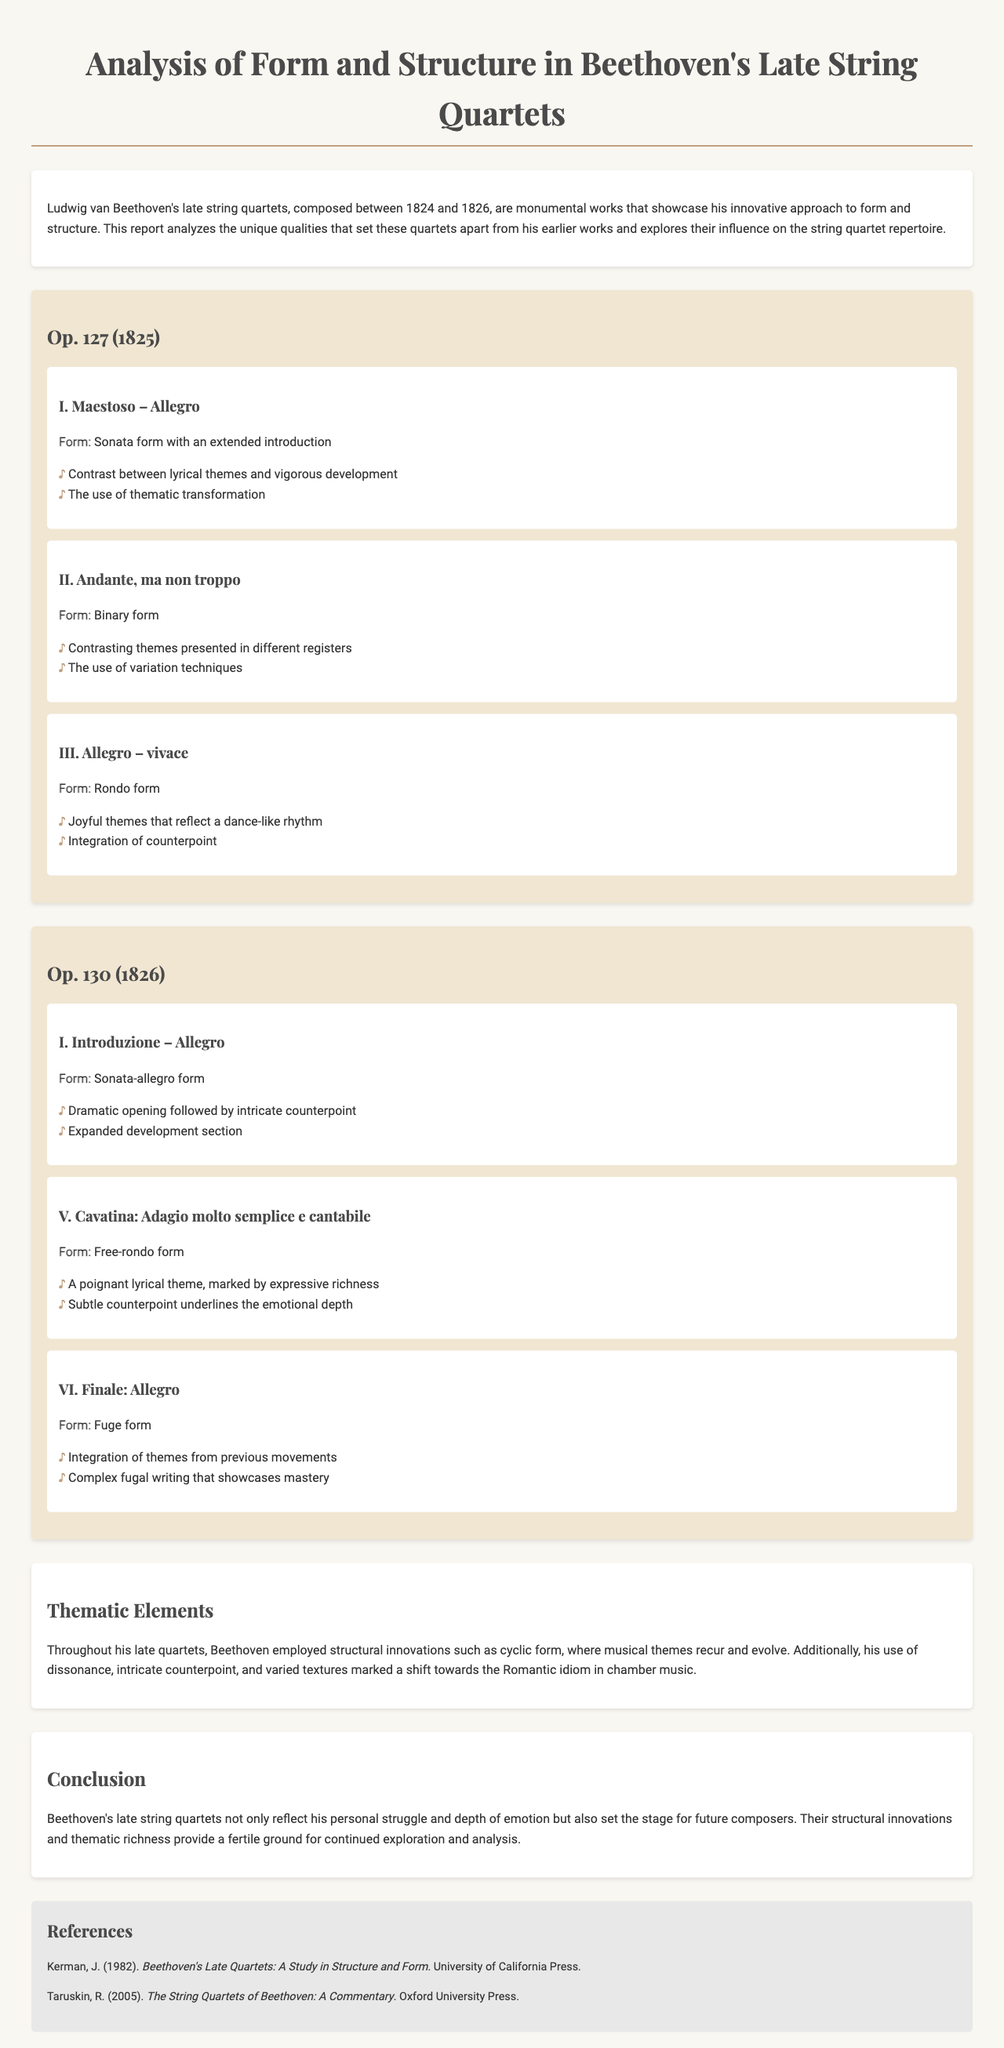What years were Beethoven's late string quartets composed? The document states that Beethoven's late string quartets were composed between 1824 and 1826.
Answer: 1824 and 1826 What is the form of the first movement of Op. 127? The document mentions that the first movement of Op. 127 is in sonata form with an extended introduction.
Answer: Sonata form with an extended introduction How many movements are there in Op. 130? The document lists three movements for Op. 130 in the analysis sections.
Answer: Three What thematic innovation is highlighted in the thematic elements section? The document refers to the use of cyclic form as a thematic innovation throughout Beethoven's late quartets.
Answer: Cyclic form What is the title of the second movement in Op. 130? The second movement of Op. 130 is titled "Cavatina: Adagio molto semplice e cantabile."
Answer: Cavatina: Adagio molto semplice e cantabile What type of form does the last movement of Op. 130 use? The document states that the last movement of Op. 130 uses fugal form.
Answer: Fugal form Who authored the reference titled "Beethoven's Late Quartets: A Study in Structure and Form"? The document shows that the author of this reference is J. Kerman.
Answer: J. Kerman What primary emotional aspect do Beethoven's late quartets reflect according to the conclusion? The conclusion emphasizes that Beethoven's late quartets reflect his personal struggle and depth of emotion.
Answer: Personal struggle and depth of emotion 